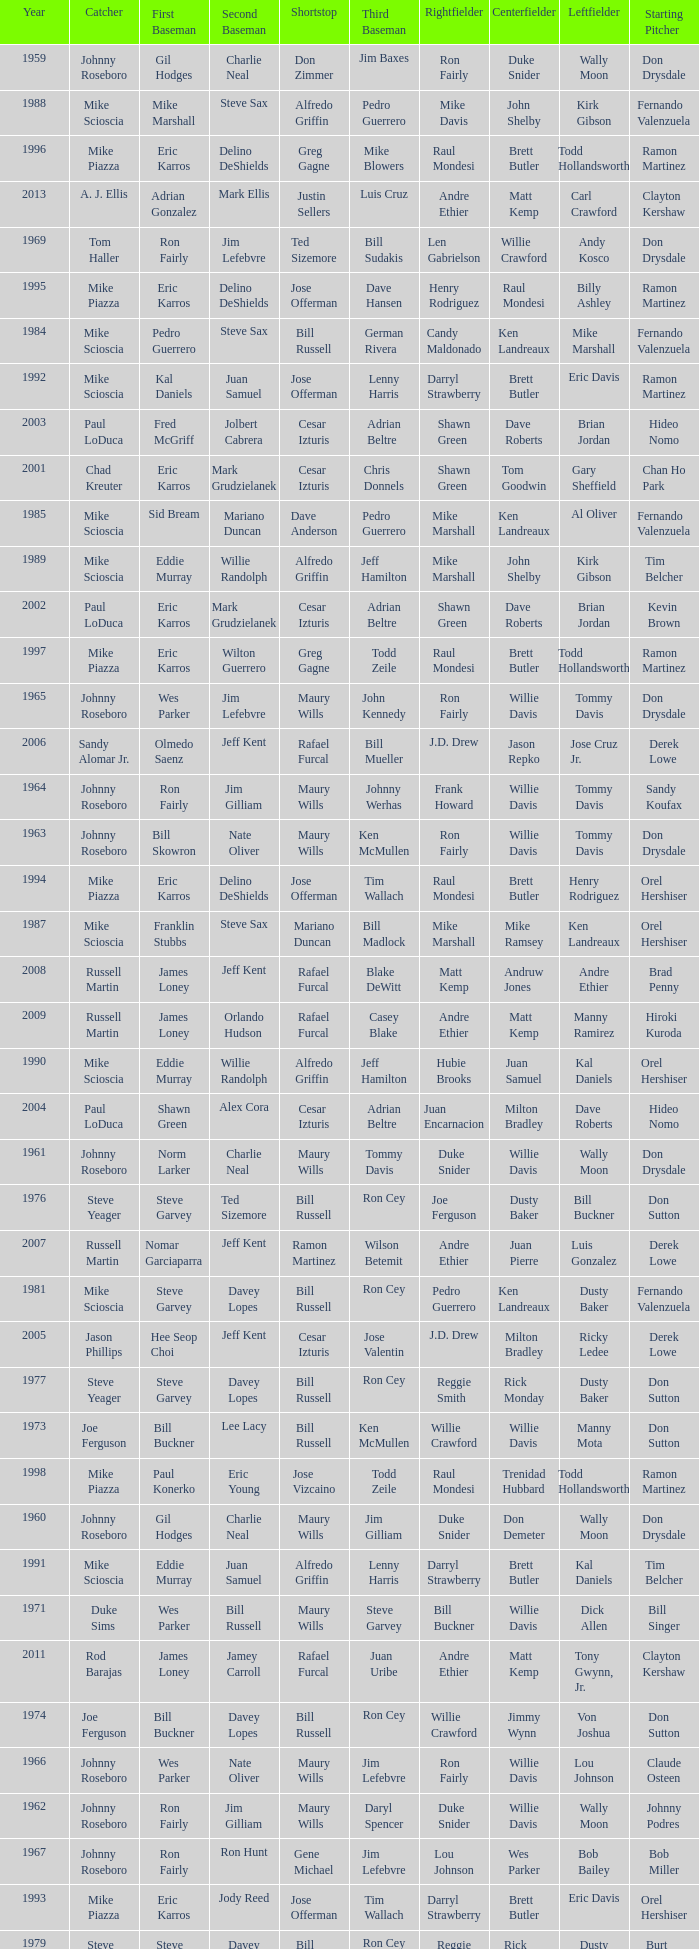Who was the SS when jim lefebvre was at 2nd, willie davis at CF, and don drysdale was the SP. Maury Wills. 